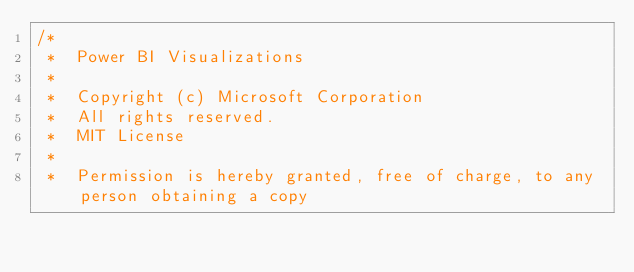Convert code to text. <code><loc_0><loc_0><loc_500><loc_500><_TypeScript_>/*
 *  Power BI Visualizations
 *
 *  Copyright (c) Microsoft Corporation
 *  All rights reserved.
 *  MIT License
 *
 *  Permission is hereby granted, free of charge, to any person obtaining a copy</code> 